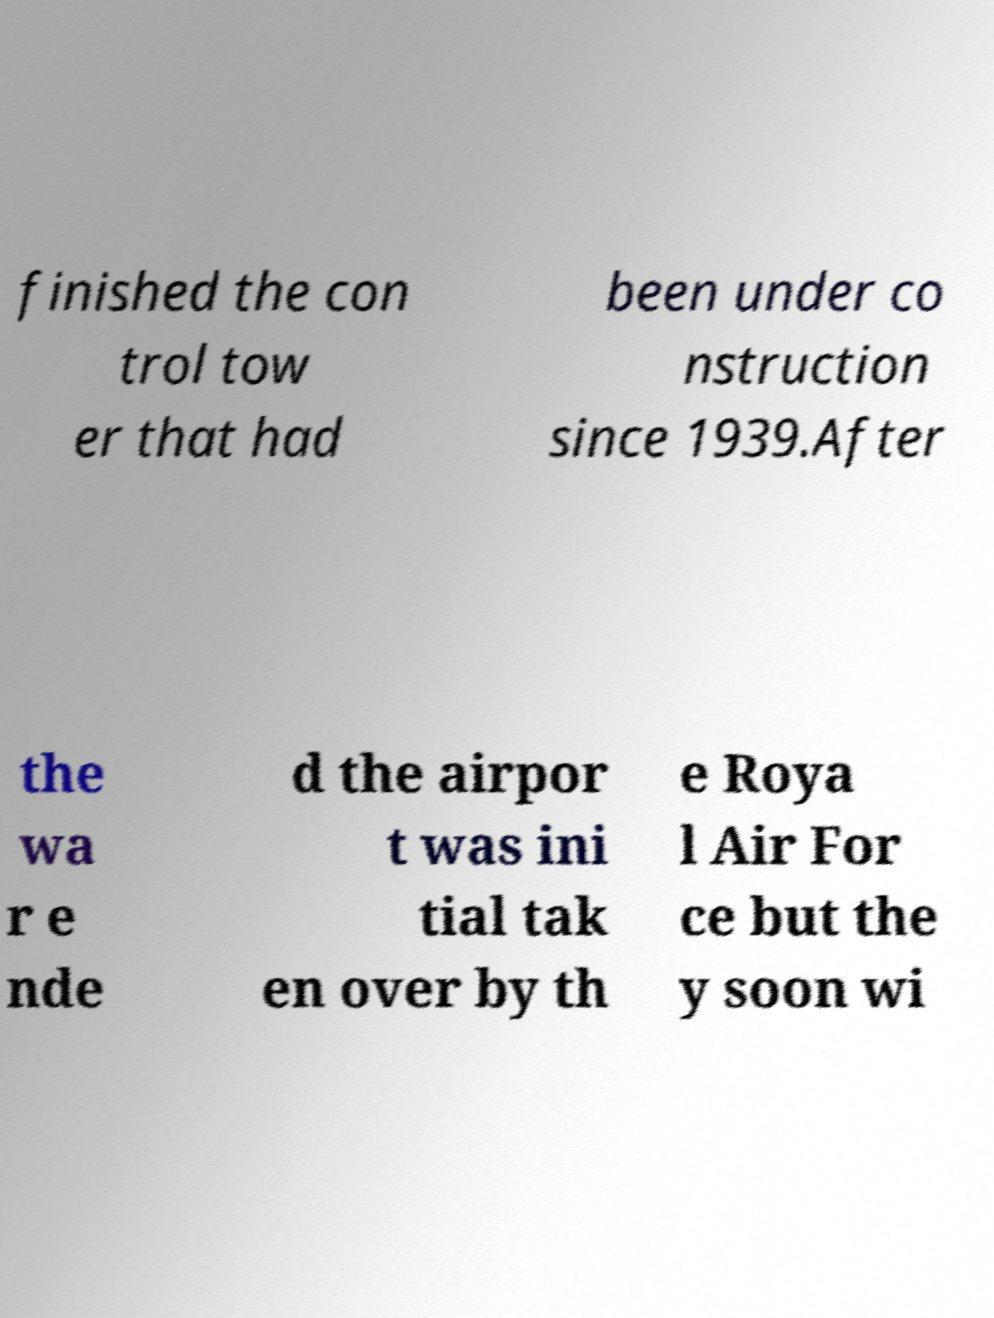Please read and relay the text visible in this image. What does it say? finished the con trol tow er that had been under co nstruction since 1939.After the wa r e nde d the airpor t was ini tial tak en over by th e Roya l Air For ce but the y soon wi 